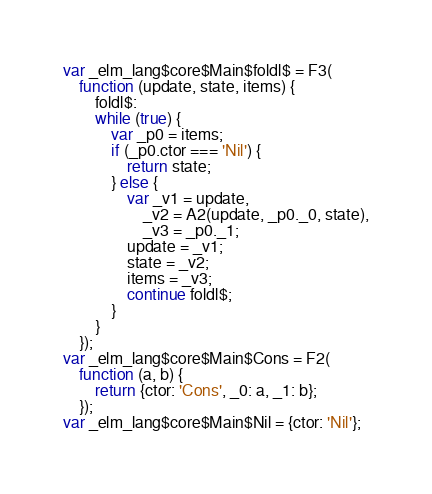<code> <loc_0><loc_0><loc_500><loc_500><_JavaScript_>var _elm_lang$core$Main$foldl$ = F3(
	function (update, state, items) {
		foldl$:
		while (true) {
			var _p0 = items;
			if (_p0.ctor === 'Nil') {
				return state;
			} else {
				var _v1 = update,
					_v2 = A2(update, _p0._0, state),
					_v3 = _p0._1;
				update = _v1;
				state = _v2;
				items = _v3;
				continue foldl$;
			}
		}
	});
var _elm_lang$core$Main$Cons = F2(
	function (a, b) {
		return {ctor: 'Cons', _0: a, _1: b};
	});
var _elm_lang$core$Main$Nil = {ctor: 'Nil'};
</code> 